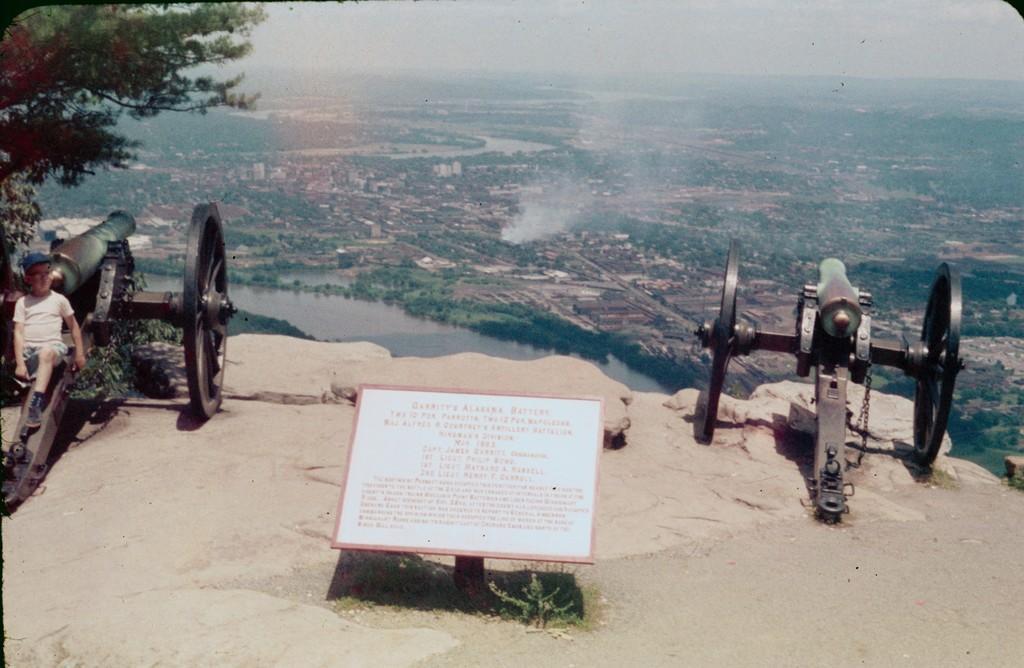Please provide a concise description of this image. There are two war equipment and a kid is sitting on one of the equipment and in the left there is a tree,in the background there is a river and beside the river there is a city. 